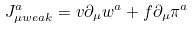Convert formula to latex. <formula><loc_0><loc_0><loc_500><loc_500>J ^ { a } _ { \mu { w e a k } } = v \partial _ { \mu } w ^ { a } + f \partial _ { \mu } \pi ^ { a }</formula> 